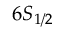<formula> <loc_0><loc_0><loc_500><loc_500>6 S _ { 1 / 2 }</formula> 